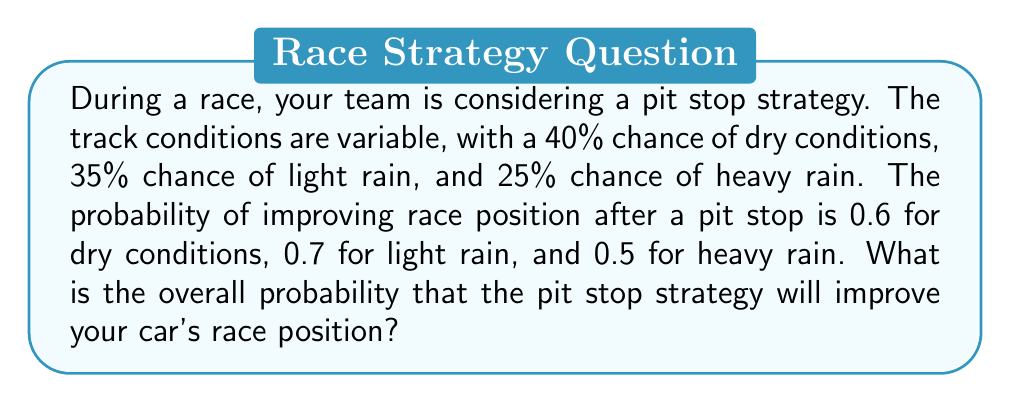Can you solve this math problem? Let's approach this step-by-step using the law of total probability:

1) Define events:
   A: Pit stop improves race position
   D: Dry conditions
   L: Light rain
   H: Heavy rain

2) Given probabilities:
   $P(D) = 0.40$, $P(L) = 0.35$, $P(H) = 0.25$
   $P(A|D) = 0.60$, $P(A|L) = 0.70$, $P(A|H) = 0.50$

3) Law of Total Probability:
   $$P(A) = P(A|D)P(D) + P(A|L)P(L) + P(A|H)P(H)$$

4) Substitute the values:
   $$P(A) = (0.60)(0.40) + (0.70)(0.35) + (0.50)(0.25)$$

5) Calculate:
   $$P(A) = 0.24 + 0.245 + 0.125 = 0.61$$

Therefore, the overall probability of improving race position with the pit stop strategy is 0.61 or 61%.
Answer: 0.61 